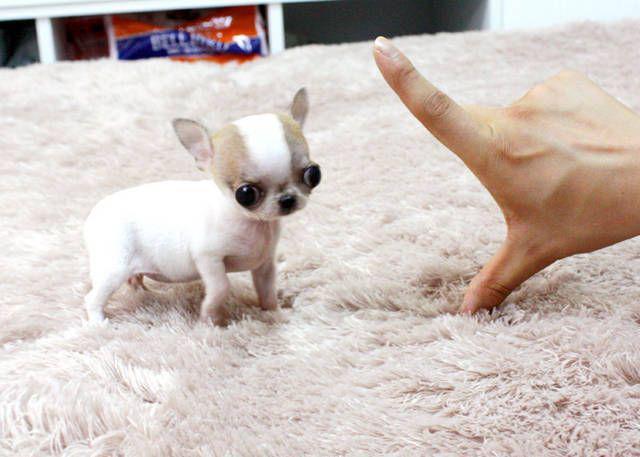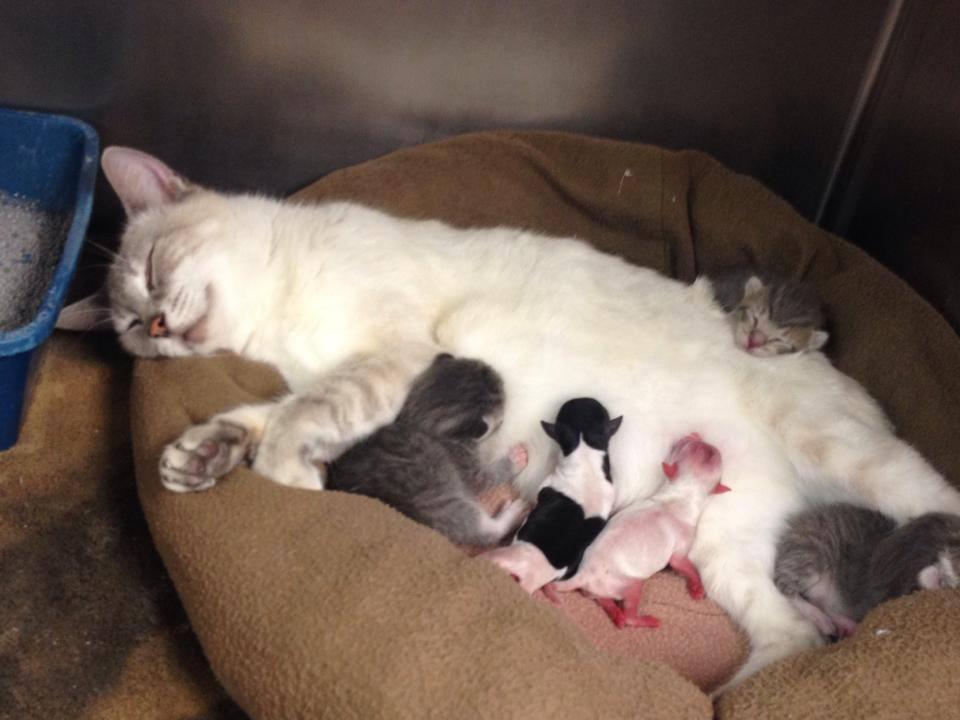The first image is the image on the left, the second image is the image on the right. For the images displayed, is the sentence "At least one animal is drinking milk." factually correct? Answer yes or no. Yes. The first image is the image on the left, the second image is the image on the right. Examine the images to the left and right. Is the description "There are two chihuahua puppies." accurate? Answer yes or no. No. 